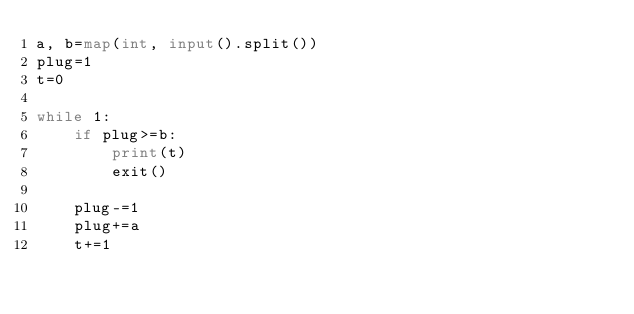<code> <loc_0><loc_0><loc_500><loc_500><_Python_>a, b=map(int, input().split())
plug=1
t=0

while 1:
    if plug>=b:
        print(t)
        exit()
    
    plug-=1
    plug+=a
    t+=1</code> 